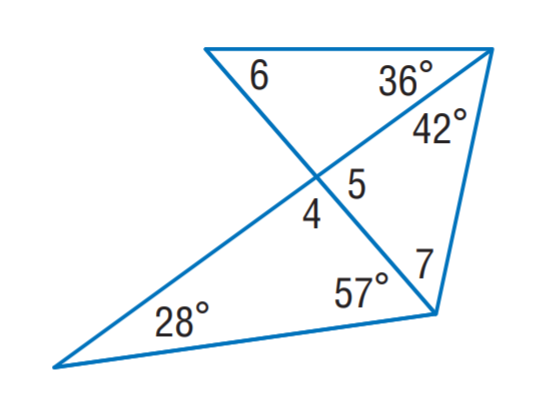Question: Find m \angle 6.
Choices:
A. 30
B. 49
C. 53
D. 85
Answer with the letter. Answer: B Question: Find m \angle 7.
Choices:
A. 30
B. 37
C. 49
D. 53
Answer with the letter. Answer: D Question: Find m \angle 4.
Choices:
A. 53
B. 85
C. 95
D. 100
Answer with the letter. Answer: C Question: Find m \angle 5.
Choices:
A. 53
B. 75
C. 85
D. 88
Answer with the letter. Answer: C 